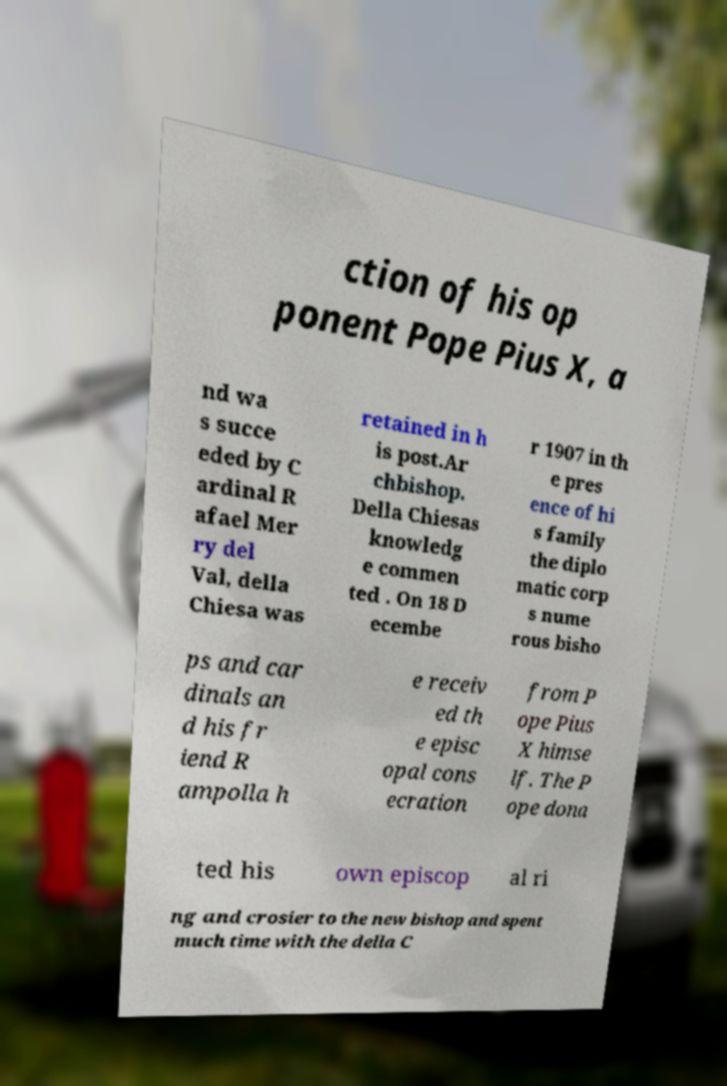For documentation purposes, I need the text within this image transcribed. Could you provide that? ction of his op ponent Pope Pius X, a nd wa s succe eded by C ardinal R afael Mer ry del Val, della Chiesa was retained in h is post.Ar chbishop. Della Chiesas knowledg e commen ted . On 18 D ecembe r 1907 in th e pres ence of hi s family the diplo matic corp s nume rous bisho ps and car dinals an d his fr iend R ampolla h e receiv ed th e episc opal cons ecration from P ope Pius X himse lf. The P ope dona ted his own episcop al ri ng and crosier to the new bishop and spent much time with the della C 